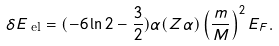<formula> <loc_0><loc_0><loc_500><loc_500>\delta E _ { \text { el} } = ( - 6 \ln 2 - \frac { 3 } { 2 } ) \alpha ( Z \alpha ) \left ( \frac { m } { M } \right ) ^ { 2 } E _ { F } .</formula> 